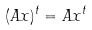Convert formula to latex. <formula><loc_0><loc_0><loc_500><loc_500>( A x ) ^ { t } = A x ^ { t }</formula> 